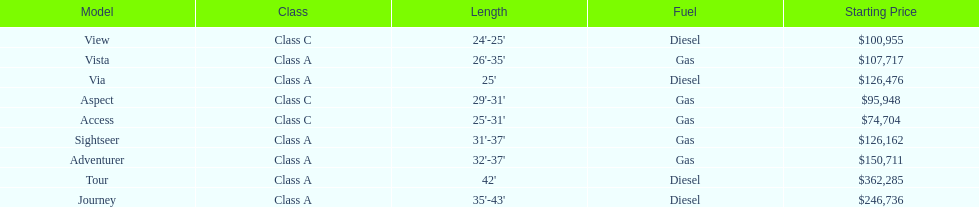What is the total number of class a models? 6. 